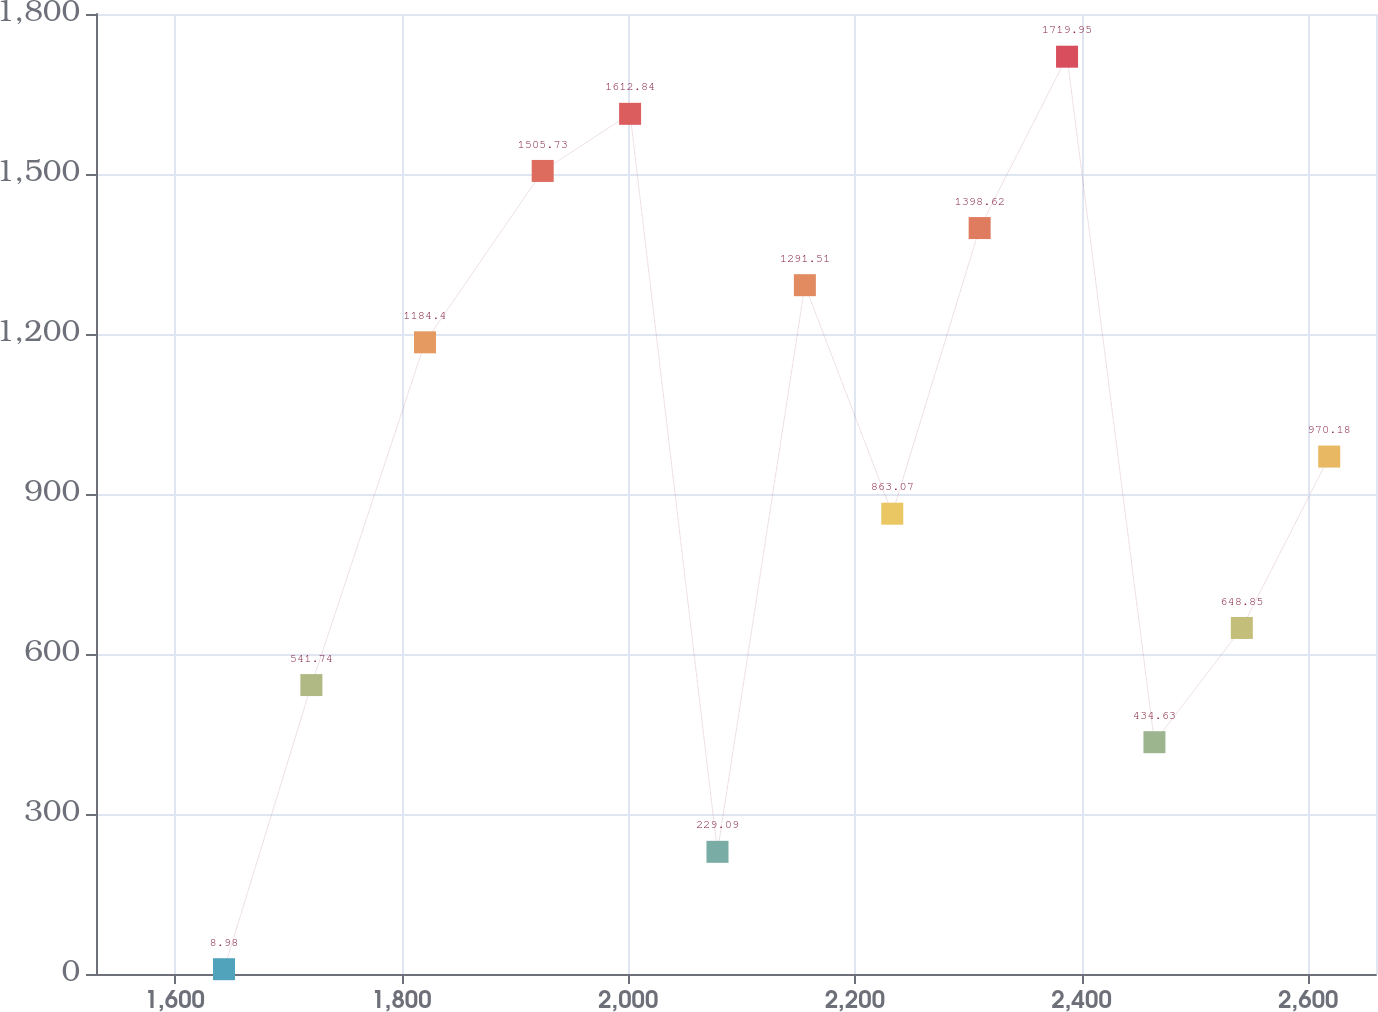Convert chart to OTSL. <chart><loc_0><loc_0><loc_500><loc_500><line_chart><ecel><fcel>Amount<nl><fcel>1643.39<fcel>8.98<nl><fcel>1720.49<fcel>541.74<nl><fcel>1820.7<fcel>1184.4<nl><fcel>1924.57<fcel>1505.73<nl><fcel>2001.67<fcel>1612.84<nl><fcel>2078.77<fcel>229.09<nl><fcel>2155.87<fcel>1291.51<nl><fcel>2232.97<fcel>863.07<nl><fcel>2310.07<fcel>1398.62<nl><fcel>2387.17<fcel>1719.95<nl><fcel>2464.27<fcel>434.63<nl><fcel>2541.37<fcel>648.85<nl><fcel>2618.47<fcel>970.18<nl><fcel>2695.57<fcel>1077.29<nl><fcel>2772.67<fcel>755.96<nl></chart> 